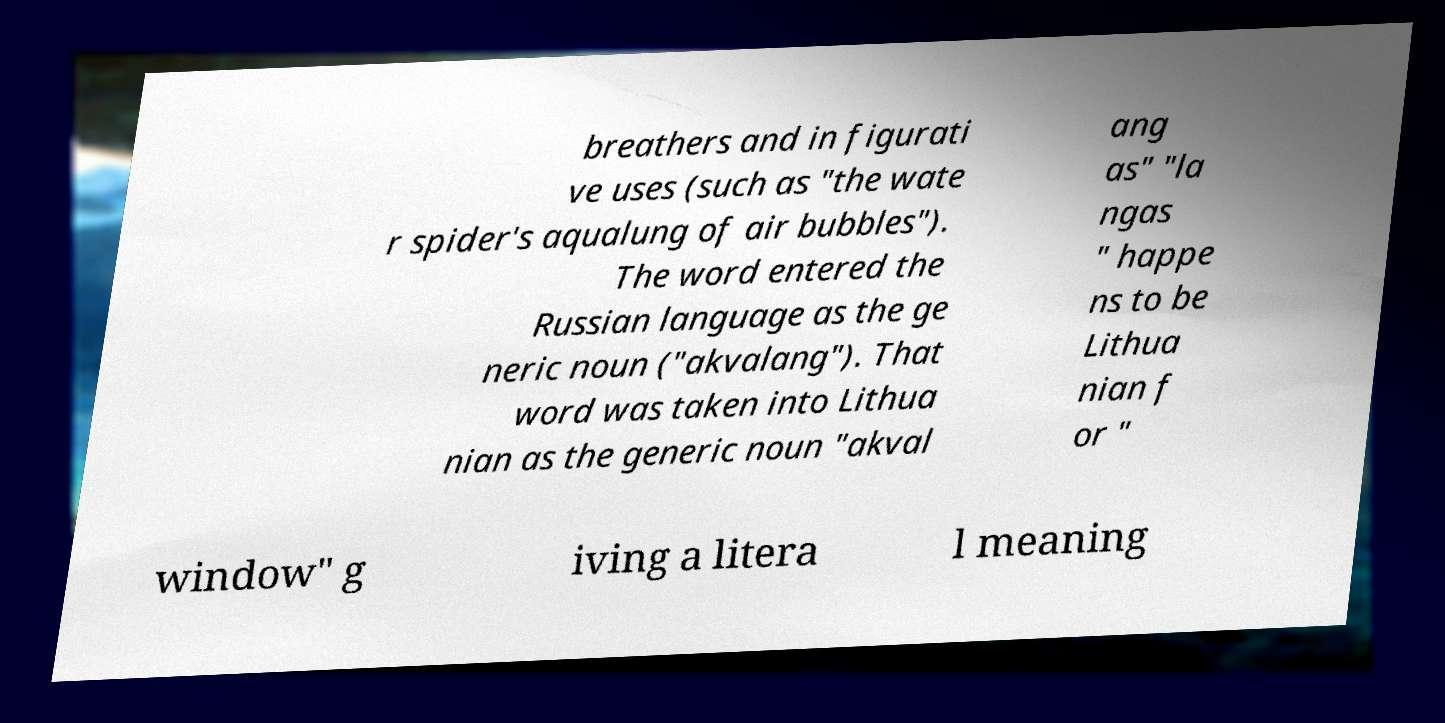Can you accurately transcribe the text from the provided image for me? breathers and in figurati ve uses (such as "the wate r spider's aqualung of air bubbles"). The word entered the Russian language as the ge neric noun ("akvalang"). That word was taken into Lithua nian as the generic noun "akval ang as" "la ngas " happe ns to be Lithua nian f or " window" g iving a litera l meaning 